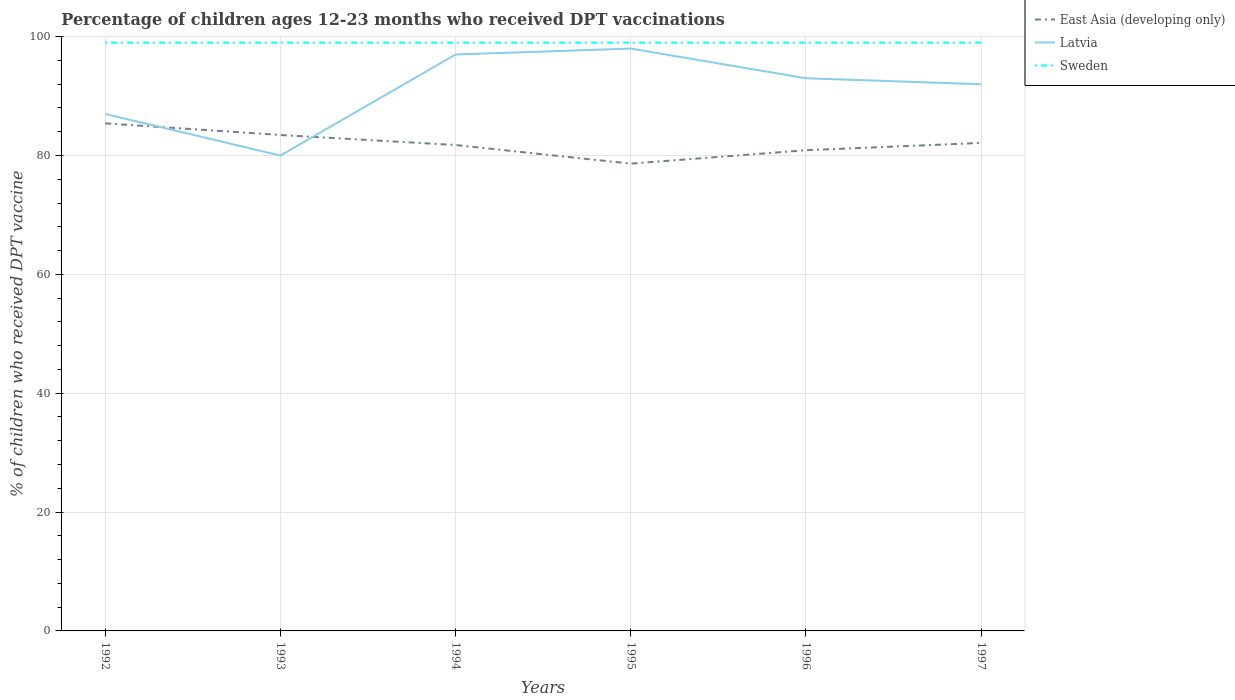How many different coloured lines are there?
Provide a succinct answer. 3. Is the number of lines equal to the number of legend labels?
Keep it short and to the point. Yes. Across all years, what is the maximum percentage of children who received DPT vaccination in East Asia (developing only)?
Make the answer very short. 78.63. What is the total percentage of children who received DPT vaccination in Latvia in the graph?
Give a very brief answer. -17. What is the difference between the highest and the second highest percentage of children who received DPT vaccination in East Asia (developing only)?
Your answer should be compact. 6.78. What is the difference between the highest and the lowest percentage of children who received DPT vaccination in Latvia?
Make the answer very short. 4. How many lines are there?
Your answer should be very brief. 3. How many years are there in the graph?
Offer a terse response. 6. What is the difference between two consecutive major ticks on the Y-axis?
Give a very brief answer. 20. Are the values on the major ticks of Y-axis written in scientific E-notation?
Ensure brevity in your answer.  No. Does the graph contain any zero values?
Make the answer very short. No. Where does the legend appear in the graph?
Your answer should be compact. Top right. What is the title of the graph?
Your response must be concise. Percentage of children ages 12-23 months who received DPT vaccinations. Does "Czech Republic" appear as one of the legend labels in the graph?
Give a very brief answer. No. What is the label or title of the Y-axis?
Provide a short and direct response. % of children who received DPT vaccine. What is the % of children who received DPT vaccine of East Asia (developing only) in 1992?
Offer a terse response. 85.42. What is the % of children who received DPT vaccine of Sweden in 1992?
Ensure brevity in your answer.  99. What is the % of children who received DPT vaccine of East Asia (developing only) in 1993?
Keep it short and to the point. 83.46. What is the % of children who received DPT vaccine of Latvia in 1993?
Your answer should be very brief. 80. What is the % of children who received DPT vaccine of East Asia (developing only) in 1994?
Your answer should be compact. 81.77. What is the % of children who received DPT vaccine of Latvia in 1994?
Make the answer very short. 97. What is the % of children who received DPT vaccine of East Asia (developing only) in 1995?
Ensure brevity in your answer.  78.63. What is the % of children who received DPT vaccine in East Asia (developing only) in 1996?
Your response must be concise. 80.89. What is the % of children who received DPT vaccine in Latvia in 1996?
Your answer should be very brief. 93. What is the % of children who received DPT vaccine of Sweden in 1996?
Your answer should be compact. 99. What is the % of children who received DPT vaccine in East Asia (developing only) in 1997?
Keep it short and to the point. 82.12. What is the % of children who received DPT vaccine in Latvia in 1997?
Offer a terse response. 92. What is the % of children who received DPT vaccine of Sweden in 1997?
Provide a short and direct response. 99. Across all years, what is the maximum % of children who received DPT vaccine in East Asia (developing only)?
Offer a very short reply. 85.42. Across all years, what is the maximum % of children who received DPT vaccine in Sweden?
Ensure brevity in your answer.  99. Across all years, what is the minimum % of children who received DPT vaccine of East Asia (developing only)?
Keep it short and to the point. 78.63. Across all years, what is the minimum % of children who received DPT vaccine in Latvia?
Your answer should be compact. 80. What is the total % of children who received DPT vaccine in East Asia (developing only) in the graph?
Provide a short and direct response. 492.29. What is the total % of children who received DPT vaccine of Latvia in the graph?
Provide a succinct answer. 547. What is the total % of children who received DPT vaccine in Sweden in the graph?
Ensure brevity in your answer.  594. What is the difference between the % of children who received DPT vaccine in East Asia (developing only) in 1992 and that in 1993?
Keep it short and to the point. 1.96. What is the difference between the % of children who received DPT vaccine of East Asia (developing only) in 1992 and that in 1994?
Keep it short and to the point. 3.65. What is the difference between the % of children who received DPT vaccine of East Asia (developing only) in 1992 and that in 1995?
Ensure brevity in your answer.  6.78. What is the difference between the % of children who received DPT vaccine of Latvia in 1992 and that in 1995?
Provide a short and direct response. -11. What is the difference between the % of children who received DPT vaccine in East Asia (developing only) in 1992 and that in 1996?
Give a very brief answer. 4.52. What is the difference between the % of children who received DPT vaccine of Latvia in 1992 and that in 1996?
Provide a succinct answer. -6. What is the difference between the % of children who received DPT vaccine in East Asia (developing only) in 1992 and that in 1997?
Keep it short and to the point. 3.3. What is the difference between the % of children who received DPT vaccine of Latvia in 1992 and that in 1997?
Keep it short and to the point. -5. What is the difference between the % of children who received DPT vaccine in Sweden in 1992 and that in 1997?
Ensure brevity in your answer.  0. What is the difference between the % of children who received DPT vaccine of East Asia (developing only) in 1993 and that in 1994?
Offer a very short reply. 1.69. What is the difference between the % of children who received DPT vaccine of Latvia in 1993 and that in 1994?
Offer a terse response. -17. What is the difference between the % of children who received DPT vaccine of East Asia (developing only) in 1993 and that in 1995?
Your answer should be very brief. 4.82. What is the difference between the % of children who received DPT vaccine of Sweden in 1993 and that in 1995?
Your response must be concise. 0. What is the difference between the % of children who received DPT vaccine in East Asia (developing only) in 1993 and that in 1996?
Ensure brevity in your answer.  2.56. What is the difference between the % of children who received DPT vaccine in East Asia (developing only) in 1993 and that in 1997?
Your answer should be very brief. 1.34. What is the difference between the % of children who received DPT vaccine of East Asia (developing only) in 1994 and that in 1995?
Your response must be concise. 3.14. What is the difference between the % of children who received DPT vaccine of Latvia in 1994 and that in 1995?
Offer a very short reply. -1. What is the difference between the % of children who received DPT vaccine of East Asia (developing only) in 1994 and that in 1996?
Your answer should be very brief. 0.87. What is the difference between the % of children who received DPT vaccine in East Asia (developing only) in 1994 and that in 1997?
Your answer should be very brief. -0.35. What is the difference between the % of children who received DPT vaccine of Sweden in 1994 and that in 1997?
Your answer should be very brief. 0. What is the difference between the % of children who received DPT vaccine in East Asia (developing only) in 1995 and that in 1996?
Offer a terse response. -2.26. What is the difference between the % of children who received DPT vaccine of East Asia (developing only) in 1995 and that in 1997?
Provide a short and direct response. -3.49. What is the difference between the % of children who received DPT vaccine of Latvia in 1995 and that in 1997?
Your response must be concise. 6. What is the difference between the % of children who received DPT vaccine of Sweden in 1995 and that in 1997?
Offer a terse response. 0. What is the difference between the % of children who received DPT vaccine in East Asia (developing only) in 1996 and that in 1997?
Offer a very short reply. -1.22. What is the difference between the % of children who received DPT vaccine in Sweden in 1996 and that in 1997?
Make the answer very short. 0. What is the difference between the % of children who received DPT vaccine of East Asia (developing only) in 1992 and the % of children who received DPT vaccine of Latvia in 1993?
Offer a very short reply. 5.42. What is the difference between the % of children who received DPT vaccine in East Asia (developing only) in 1992 and the % of children who received DPT vaccine in Sweden in 1993?
Offer a terse response. -13.58. What is the difference between the % of children who received DPT vaccine in East Asia (developing only) in 1992 and the % of children who received DPT vaccine in Latvia in 1994?
Your answer should be compact. -11.58. What is the difference between the % of children who received DPT vaccine in East Asia (developing only) in 1992 and the % of children who received DPT vaccine in Sweden in 1994?
Provide a succinct answer. -13.58. What is the difference between the % of children who received DPT vaccine of East Asia (developing only) in 1992 and the % of children who received DPT vaccine of Latvia in 1995?
Ensure brevity in your answer.  -12.58. What is the difference between the % of children who received DPT vaccine of East Asia (developing only) in 1992 and the % of children who received DPT vaccine of Sweden in 1995?
Offer a very short reply. -13.58. What is the difference between the % of children who received DPT vaccine of Latvia in 1992 and the % of children who received DPT vaccine of Sweden in 1995?
Offer a very short reply. -12. What is the difference between the % of children who received DPT vaccine in East Asia (developing only) in 1992 and the % of children who received DPT vaccine in Latvia in 1996?
Provide a succinct answer. -7.58. What is the difference between the % of children who received DPT vaccine of East Asia (developing only) in 1992 and the % of children who received DPT vaccine of Sweden in 1996?
Keep it short and to the point. -13.58. What is the difference between the % of children who received DPT vaccine in Latvia in 1992 and the % of children who received DPT vaccine in Sweden in 1996?
Provide a succinct answer. -12. What is the difference between the % of children who received DPT vaccine of East Asia (developing only) in 1992 and the % of children who received DPT vaccine of Latvia in 1997?
Offer a terse response. -6.58. What is the difference between the % of children who received DPT vaccine in East Asia (developing only) in 1992 and the % of children who received DPT vaccine in Sweden in 1997?
Offer a terse response. -13.58. What is the difference between the % of children who received DPT vaccine in East Asia (developing only) in 1993 and the % of children who received DPT vaccine in Latvia in 1994?
Provide a succinct answer. -13.54. What is the difference between the % of children who received DPT vaccine of East Asia (developing only) in 1993 and the % of children who received DPT vaccine of Sweden in 1994?
Your response must be concise. -15.54. What is the difference between the % of children who received DPT vaccine of Latvia in 1993 and the % of children who received DPT vaccine of Sweden in 1994?
Offer a very short reply. -19. What is the difference between the % of children who received DPT vaccine in East Asia (developing only) in 1993 and the % of children who received DPT vaccine in Latvia in 1995?
Offer a terse response. -14.54. What is the difference between the % of children who received DPT vaccine of East Asia (developing only) in 1993 and the % of children who received DPT vaccine of Sweden in 1995?
Provide a short and direct response. -15.54. What is the difference between the % of children who received DPT vaccine in East Asia (developing only) in 1993 and the % of children who received DPT vaccine in Latvia in 1996?
Ensure brevity in your answer.  -9.54. What is the difference between the % of children who received DPT vaccine in East Asia (developing only) in 1993 and the % of children who received DPT vaccine in Sweden in 1996?
Your response must be concise. -15.54. What is the difference between the % of children who received DPT vaccine of Latvia in 1993 and the % of children who received DPT vaccine of Sweden in 1996?
Ensure brevity in your answer.  -19. What is the difference between the % of children who received DPT vaccine of East Asia (developing only) in 1993 and the % of children who received DPT vaccine of Latvia in 1997?
Your response must be concise. -8.54. What is the difference between the % of children who received DPT vaccine of East Asia (developing only) in 1993 and the % of children who received DPT vaccine of Sweden in 1997?
Provide a succinct answer. -15.54. What is the difference between the % of children who received DPT vaccine in Latvia in 1993 and the % of children who received DPT vaccine in Sweden in 1997?
Keep it short and to the point. -19. What is the difference between the % of children who received DPT vaccine of East Asia (developing only) in 1994 and the % of children who received DPT vaccine of Latvia in 1995?
Keep it short and to the point. -16.23. What is the difference between the % of children who received DPT vaccine of East Asia (developing only) in 1994 and the % of children who received DPT vaccine of Sweden in 1995?
Ensure brevity in your answer.  -17.23. What is the difference between the % of children who received DPT vaccine of Latvia in 1994 and the % of children who received DPT vaccine of Sweden in 1995?
Make the answer very short. -2. What is the difference between the % of children who received DPT vaccine in East Asia (developing only) in 1994 and the % of children who received DPT vaccine in Latvia in 1996?
Ensure brevity in your answer.  -11.23. What is the difference between the % of children who received DPT vaccine of East Asia (developing only) in 1994 and the % of children who received DPT vaccine of Sweden in 1996?
Offer a very short reply. -17.23. What is the difference between the % of children who received DPT vaccine in East Asia (developing only) in 1994 and the % of children who received DPT vaccine in Latvia in 1997?
Keep it short and to the point. -10.23. What is the difference between the % of children who received DPT vaccine in East Asia (developing only) in 1994 and the % of children who received DPT vaccine in Sweden in 1997?
Make the answer very short. -17.23. What is the difference between the % of children who received DPT vaccine in Latvia in 1994 and the % of children who received DPT vaccine in Sweden in 1997?
Provide a succinct answer. -2. What is the difference between the % of children who received DPT vaccine of East Asia (developing only) in 1995 and the % of children who received DPT vaccine of Latvia in 1996?
Your response must be concise. -14.37. What is the difference between the % of children who received DPT vaccine in East Asia (developing only) in 1995 and the % of children who received DPT vaccine in Sweden in 1996?
Offer a terse response. -20.37. What is the difference between the % of children who received DPT vaccine in Latvia in 1995 and the % of children who received DPT vaccine in Sweden in 1996?
Ensure brevity in your answer.  -1. What is the difference between the % of children who received DPT vaccine in East Asia (developing only) in 1995 and the % of children who received DPT vaccine in Latvia in 1997?
Ensure brevity in your answer.  -13.37. What is the difference between the % of children who received DPT vaccine of East Asia (developing only) in 1995 and the % of children who received DPT vaccine of Sweden in 1997?
Make the answer very short. -20.37. What is the difference between the % of children who received DPT vaccine in East Asia (developing only) in 1996 and the % of children who received DPT vaccine in Latvia in 1997?
Offer a very short reply. -11.11. What is the difference between the % of children who received DPT vaccine in East Asia (developing only) in 1996 and the % of children who received DPT vaccine in Sweden in 1997?
Your answer should be very brief. -18.11. What is the difference between the % of children who received DPT vaccine in Latvia in 1996 and the % of children who received DPT vaccine in Sweden in 1997?
Provide a short and direct response. -6. What is the average % of children who received DPT vaccine in East Asia (developing only) per year?
Your answer should be compact. 82.05. What is the average % of children who received DPT vaccine of Latvia per year?
Give a very brief answer. 91.17. In the year 1992, what is the difference between the % of children who received DPT vaccine of East Asia (developing only) and % of children who received DPT vaccine of Latvia?
Keep it short and to the point. -1.58. In the year 1992, what is the difference between the % of children who received DPT vaccine in East Asia (developing only) and % of children who received DPT vaccine in Sweden?
Ensure brevity in your answer.  -13.58. In the year 1992, what is the difference between the % of children who received DPT vaccine of Latvia and % of children who received DPT vaccine of Sweden?
Your response must be concise. -12. In the year 1993, what is the difference between the % of children who received DPT vaccine in East Asia (developing only) and % of children who received DPT vaccine in Latvia?
Make the answer very short. 3.46. In the year 1993, what is the difference between the % of children who received DPT vaccine in East Asia (developing only) and % of children who received DPT vaccine in Sweden?
Offer a terse response. -15.54. In the year 1994, what is the difference between the % of children who received DPT vaccine in East Asia (developing only) and % of children who received DPT vaccine in Latvia?
Offer a very short reply. -15.23. In the year 1994, what is the difference between the % of children who received DPT vaccine in East Asia (developing only) and % of children who received DPT vaccine in Sweden?
Your answer should be very brief. -17.23. In the year 1994, what is the difference between the % of children who received DPT vaccine in Latvia and % of children who received DPT vaccine in Sweden?
Offer a terse response. -2. In the year 1995, what is the difference between the % of children who received DPT vaccine in East Asia (developing only) and % of children who received DPT vaccine in Latvia?
Your answer should be very brief. -19.37. In the year 1995, what is the difference between the % of children who received DPT vaccine in East Asia (developing only) and % of children who received DPT vaccine in Sweden?
Give a very brief answer. -20.37. In the year 1995, what is the difference between the % of children who received DPT vaccine of Latvia and % of children who received DPT vaccine of Sweden?
Make the answer very short. -1. In the year 1996, what is the difference between the % of children who received DPT vaccine in East Asia (developing only) and % of children who received DPT vaccine in Latvia?
Your response must be concise. -12.11. In the year 1996, what is the difference between the % of children who received DPT vaccine in East Asia (developing only) and % of children who received DPT vaccine in Sweden?
Give a very brief answer. -18.11. In the year 1996, what is the difference between the % of children who received DPT vaccine in Latvia and % of children who received DPT vaccine in Sweden?
Keep it short and to the point. -6. In the year 1997, what is the difference between the % of children who received DPT vaccine of East Asia (developing only) and % of children who received DPT vaccine of Latvia?
Your answer should be very brief. -9.88. In the year 1997, what is the difference between the % of children who received DPT vaccine in East Asia (developing only) and % of children who received DPT vaccine in Sweden?
Make the answer very short. -16.88. What is the ratio of the % of children who received DPT vaccine of East Asia (developing only) in 1992 to that in 1993?
Offer a very short reply. 1.02. What is the ratio of the % of children who received DPT vaccine in Latvia in 1992 to that in 1993?
Your answer should be compact. 1.09. What is the ratio of the % of children who received DPT vaccine of East Asia (developing only) in 1992 to that in 1994?
Keep it short and to the point. 1.04. What is the ratio of the % of children who received DPT vaccine of Latvia in 1992 to that in 1994?
Your answer should be very brief. 0.9. What is the ratio of the % of children who received DPT vaccine in East Asia (developing only) in 1992 to that in 1995?
Give a very brief answer. 1.09. What is the ratio of the % of children who received DPT vaccine in Latvia in 1992 to that in 1995?
Offer a terse response. 0.89. What is the ratio of the % of children who received DPT vaccine in Sweden in 1992 to that in 1995?
Your answer should be very brief. 1. What is the ratio of the % of children who received DPT vaccine of East Asia (developing only) in 1992 to that in 1996?
Give a very brief answer. 1.06. What is the ratio of the % of children who received DPT vaccine in Latvia in 1992 to that in 1996?
Give a very brief answer. 0.94. What is the ratio of the % of children who received DPT vaccine of Sweden in 1992 to that in 1996?
Give a very brief answer. 1. What is the ratio of the % of children who received DPT vaccine in East Asia (developing only) in 1992 to that in 1997?
Make the answer very short. 1.04. What is the ratio of the % of children who received DPT vaccine in Latvia in 1992 to that in 1997?
Your answer should be compact. 0.95. What is the ratio of the % of children who received DPT vaccine of East Asia (developing only) in 1993 to that in 1994?
Offer a very short reply. 1.02. What is the ratio of the % of children who received DPT vaccine of Latvia in 1993 to that in 1994?
Make the answer very short. 0.82. What is the ratio of the % of children who received DPT vaccine of Sweden in 1993 to that in 1994?
Ensure brevity in your answer.  1. What is the ratio of the % of children who received DPT vaccine in East Asia (developing only) in 1993 to that in 1995?
Your answer should be very brief. 1.06. What is the ratio of the % of children who received DPT vaccine of Latvia in 1993 to that in 1995?
Give a very brief answer. 0.82. What is the ratio of the % of children who received DPT vaccine in Sweden in 1993 to that in 1995?
Keep it short and to the point. 1. What is the ratio of the % of children who received DPT vaccine of East Asia (developing only) in 1993 to that in 1996?
Ensure brevity in your answer.  1.03. What is the ratio of the % of children who received DPT vaccine in Latvia in 1993 to that in 1996?
Make the answer very short. 0.86. What is the ratio of the % of children who received DPT vaccine in Sweden in 1993 to that in 1996?
Your answer should be compact. 1. What is the ratio of the % of children who received DPT vaccine in East Asia (developing only) in 1993 to that in 1997?
Offer a terse response. 1.02. What is the ratio of the % of children who received DPT vaccine of Latvia in 1993 to that in 1997?
Keep it short and to the point. 0.87. What is the ratio of the % of children who received DPT vaccine in East Asia (developing only) in 1994 to that in 1995?
Ensure brevity in your answer.  1.04. What is the ratio of the % of children who received DPT vaccine of Sweden in 1994 to that in 1995?
Offer a very short reply. 1. What is the ratio of the % of children who received DPT vaccine in East Asia (developing only) in 1994 to that in 1996?
Make the answer very short. 1.01. What is the ratio of the % of children who received DPT vaccine in Latvia in 1994 to that in 1996?
Provide a short and direct response. 1.04. What is the ratio of the % of children who received DPT vaccine in Sweden in 1994 to that in 1996?
Offer a very short reply. 1. What is the ratio of the % of children who received DPT vaccine of Latvia in 1994 to that in 1997?
Your response must be concise. 1.05. What is the ratio of the % of children who received DPT vaccine in East Asia (developing only) in 1995 to that in 1996?
Your answer should be compact. 0.97. What is the ratio of the % of children who received DPT vaccine in Latvia in 1995 to that in 1996?
Ensure brevity in your answer.  1.05. What is the ratio of the % of children who received DPT vaccine of Sweden in 1995 to that in 1996?
Keep it short and to the point. 1. What is the ratio of the % of children who received DPT vaccine in East Asia (developing only) in 1995 to that in 1997?
Make the answer very short. 0.96. What is the ratio of the % of children who received DPT vaccine of Latvia in 1995 to that in 1997?
Provide a short and direct response. 1.07. What is the ratio of the % of children who received DPT vaccine in Sweden in 1995 to that in 1997?
Your answer should be very brief. 1. What is the ratio of the % of children who received DPT vaccine in East Asia (developing only) in 1996 to that in 1997?
Give a very brief answer. 0.99. What is the ratio of the % of children who received DPT vaccine in Latvia in 1996 to that in 1997?
Your response must be concise. 1.01. What is the difference between the highest and the second highest % of children who received DPT vaccine of East Asia (developing only)?
Make the answer very short. 1.96. What is the difference between the highest and the lowest % of children who received DPT vaccine in East Asia (developing only)?
Offer a terse response. 6.78. What is the difference between the highest and the lowest % of children who received DPT vaccine in Latvia?
Your response must be concise. 18. What is the difference between the highest and the lowest % of children who received DPT vaccine in Sweden?
Your answer should be compact. 0. 